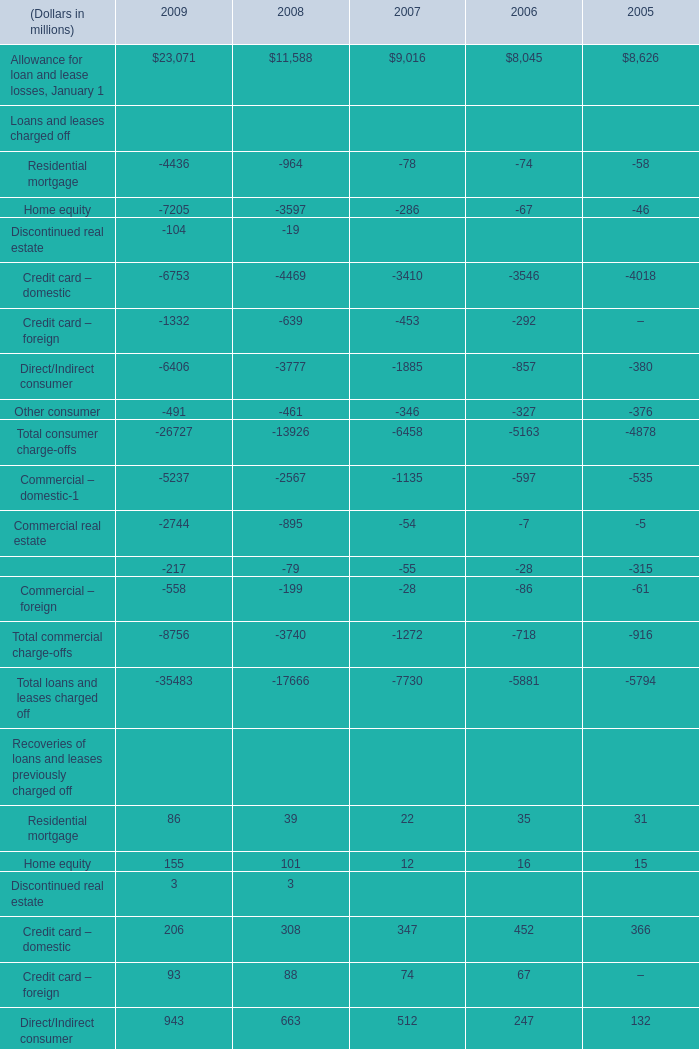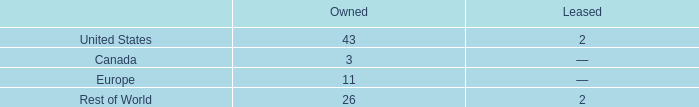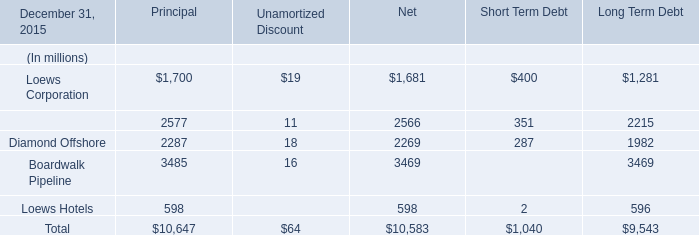what's the total amount of CNA Financial of Principal, Commercial real estate Loans and leases charged off of 2009, and Credit card – domestic Loans and leases charged off of 2008 ? 
Computations: ((2577.0 + 2744.0) + 4469.0)
Answer: 9790.0. 